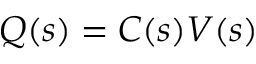Convert formula to latex. <formula><loc_0><loc_0><loc_500><loc_500>Q ( s ) = C ( s ) V ( s )</formula> 